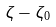<formula> <loc_0><loc_0><loc_500><loc_500>\zeta - \zeta _ { 0 }</formula> 